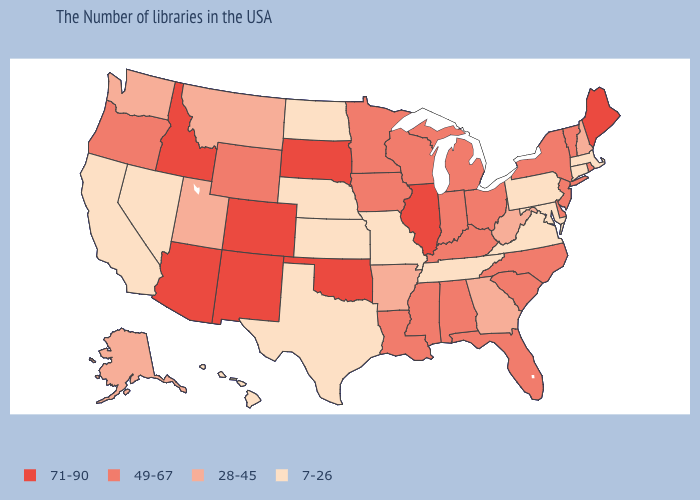Does the first symbol in the legend represent the smallest category?
Concise answer only. No. What is the lowest value in the West?
Answer briefly. 7-26. Among the states that border Idaho , does Nevada have the lowest value?
Concise answer only. Yes. What is the value of Delaware?
Be succinct. 49-67. What is the value of Wyoming?
Be succinct. 49-67. Name the states that have a value in the range 7-26?
Quick response, please. Massachusetts, Connecticut, Maryland, Pennsylvania, Virginia, Tennessee, Missouri, Kansas, Nebraska, Texas, North Dakota, Nevada, California, Hawaii. Among the states that border Nebraska , which have the highest value?
Concise answer only. South Dakota, Colorado. Among the states that border Texas , does Oklahoma have the lowest value?
Quick response, please. No. Does Georgia have a lower value than Vermont?
Concise answer only. Yes. What is the highest value in the USA?
Write a very short answer. 71-90. Does Virginia have a lower value than Louisiana?
Give a very brief answer. Yes. Name the states that have a value in the range 28-45?
Answer briefly. New Hampshire, West Virginia, Georgia, Arkansas, Utah, Montana, Washington, Alaska. What is the highest value in the West ?
Answer briefly. 71-90. What is the value of Massachusetts?
Be succinct. 7-26. What is the value of Maine?
Write a very short answer. 71-90. 